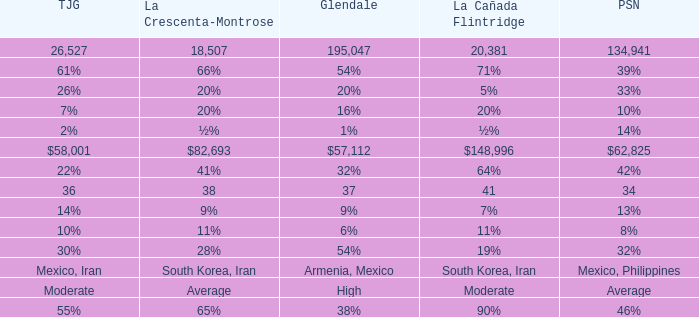When Pasadena is at 10%, what is La Crescenta-Montrose? 20%. 